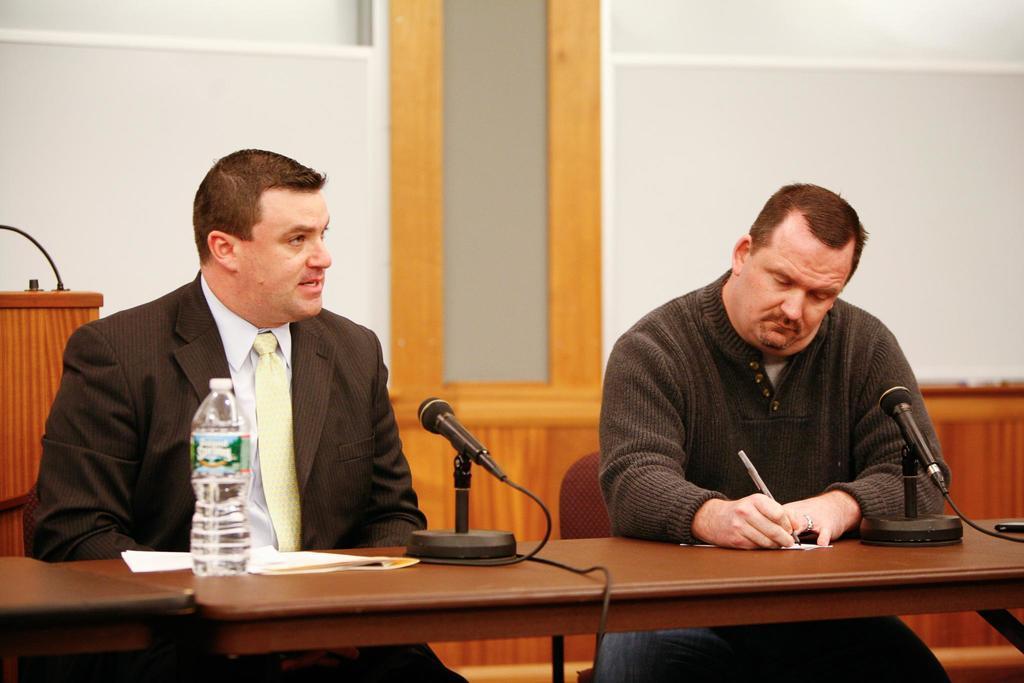Could you give a brief overview of what you see in this image? This picture is taken inside the room. In this image, on the right side and on the left side, we can see two men are sitting on the chair in front of the table. On the table, we can see a water bottle, some papers, a microphone, electric wires. On the left side, we can see a podium, on the podium, we can see some electric instrument. In the background, we can see a white color board. 